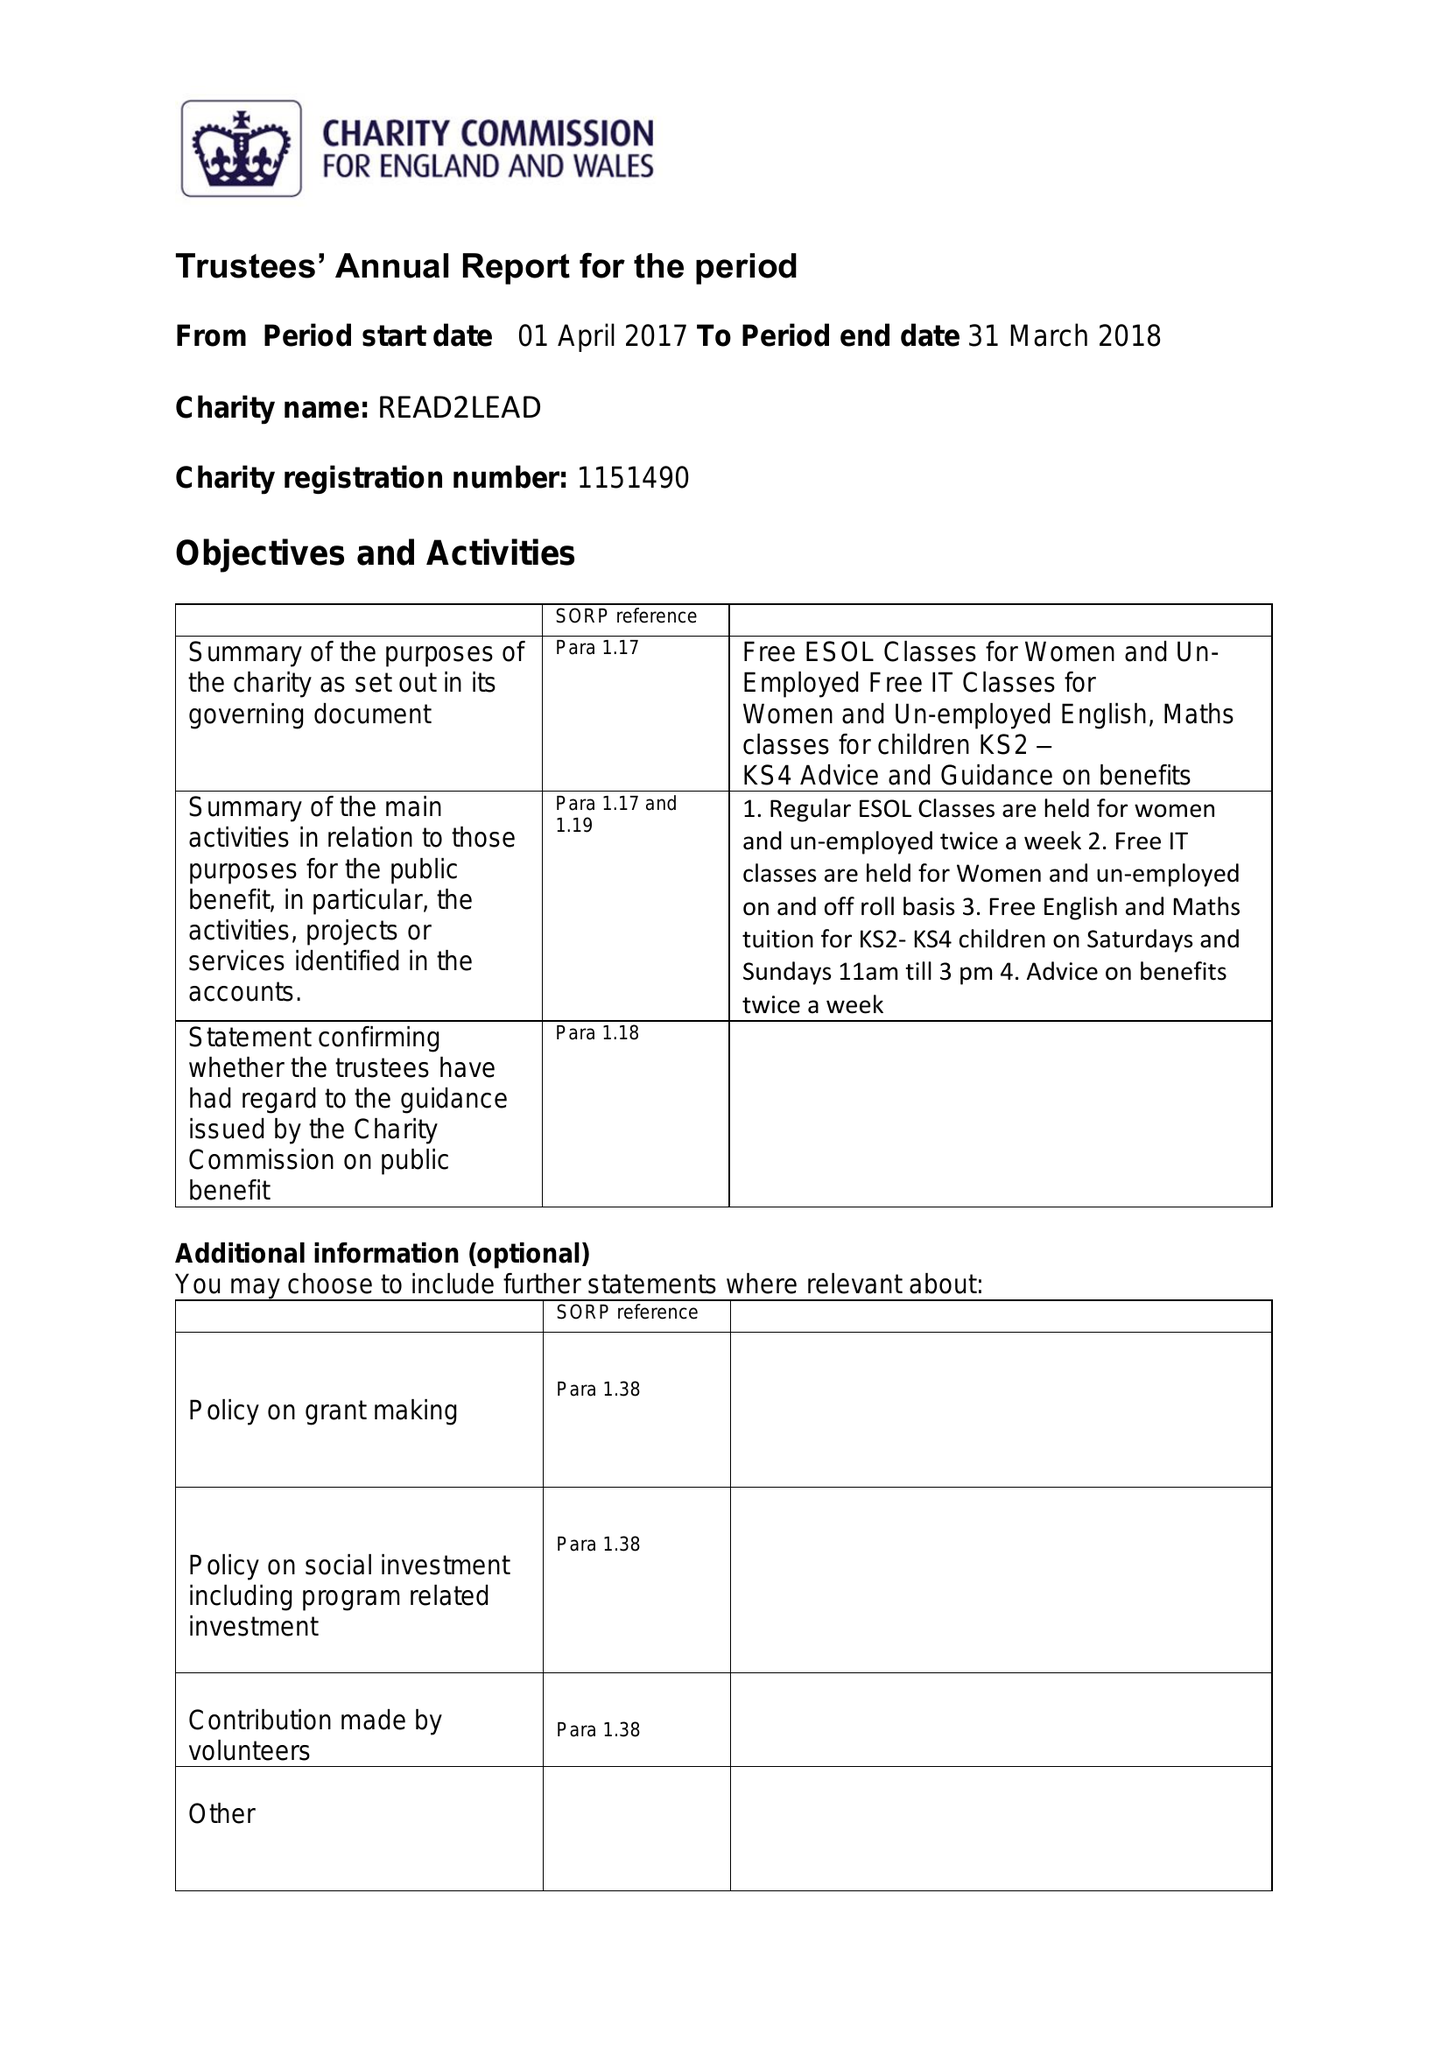What is the value for the charity_number?
Answer the question using a single word or phrase. 1151490 